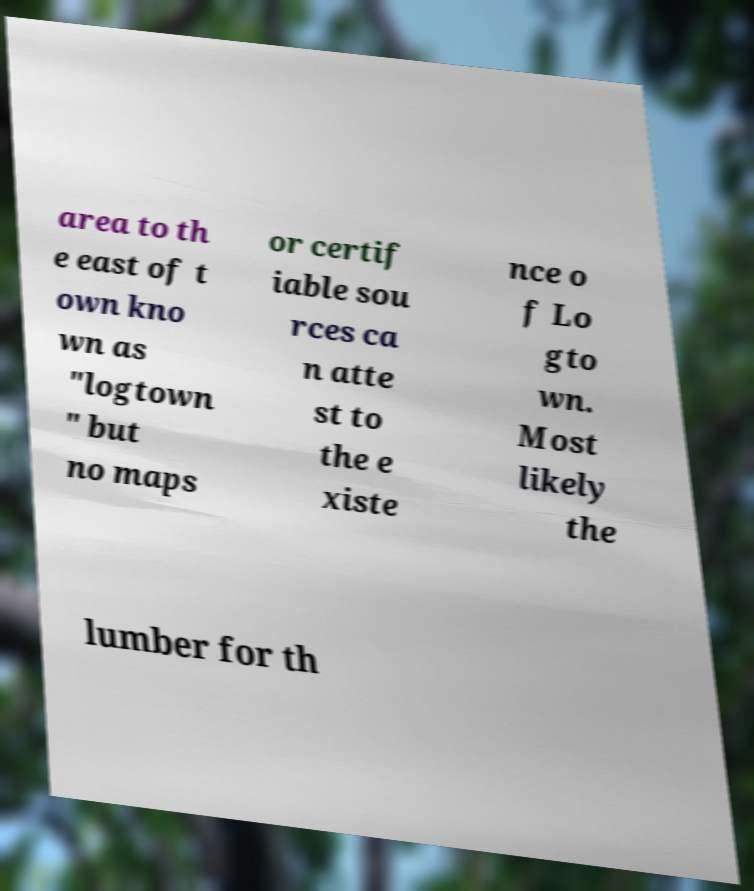Can you read and provide the text displayed in the image?This photo seems to have some interesting text. Can you extract and type it out for me? area to th e east of t own kno wn as "logtown " but no maps or certif iable sou rces ca n atte st to the e xiste nce o f Lo gto wn. Most likely the lumber for th 